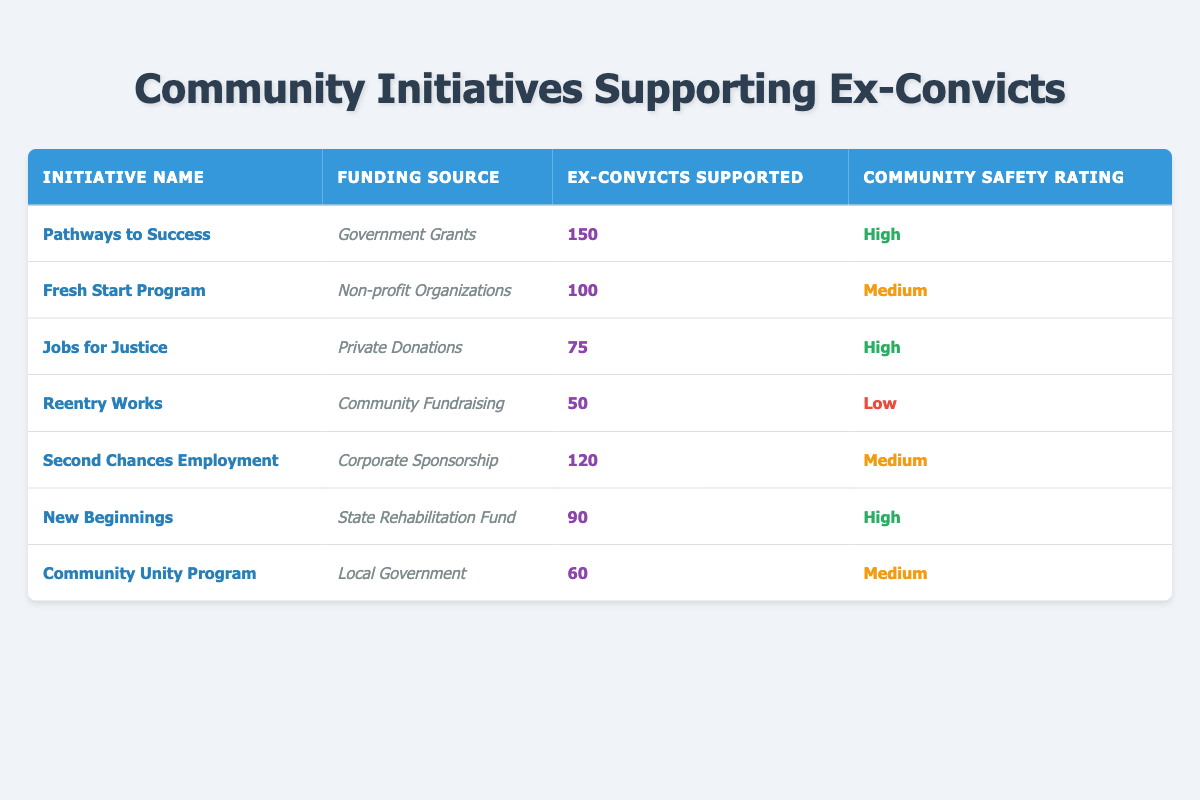What is the funding source for "Second Chances Employment"? The funding source is listed directly under the "Funding Source" column for that initiative. For "Second Chances Employment," it states "Corporate Sponsorship."
Answer: Corporate Sponsorship How many ex-convicts are supported by "Reentry Works"? By checking the table, the "Number of Ex-Convicts Supported" for "Reentry Works" is directly given as 50.
Answer: 50 Which initiative has the highest number of ex-convicts supported? The initiative with the highest number of ex-convicts supported can be determined by reviewing the "Number of Ex-Convicts Supported" column and finding the maximum value, which is 150 for "Pathways to Success."
Answer: Pathways to Success Is there an initiative with a low community safety rating that supports more than 50 ex-convicts? To answer this, we look for initiatives with a "Community Safety Rating" of "Low" in the table and verify how many ex-convicts they support. "Reentry Works" has a low rating and supports 50 ex-convicts, which does not exceed 50. Therefore, there are no initiatives that fit the criteria.
Answer: No What is the average number of ex-convicts supported across all initiatives? To find the average, we first sum the number of ex-convicts supported by each initiative: 150 + 100 + 75 + 50 + 120 + 90 + 60 = 645. Since there are 7 initiatives, we divide 645 by 7, resulting in approximately 92.14.
Answer: 92.14 How many initiatives are funded by government sources? The table lists the funding sources, and by scanning for types of government funding, we identify the following: "Government Grants," "Local Government," and "State Rehabilitation Fund." There are 4 initiatives supported by these sources.
Answer: 4 What is the total number of ex-convicts supported by initiatives rated as high for community safety? To calculate this, we find the initiatives rated "High" which are "Pathways to Success," "Jobs for Justice," and "New Beginnings." Their supported numbers are 150, 75, and 90, respectively. The total is 150 + 75 + 90 = 315.
Answer: 315 Are there any initiatives funded by non-profit organizations that have a high safety rating? Checking the table, the "Fresh Start Program" is funded by non-profit organizations and has a "Medium" safety rating, so there are no initiatives fitting the "high" safety rating that are funded by a non-profit organization.
Answer: No 